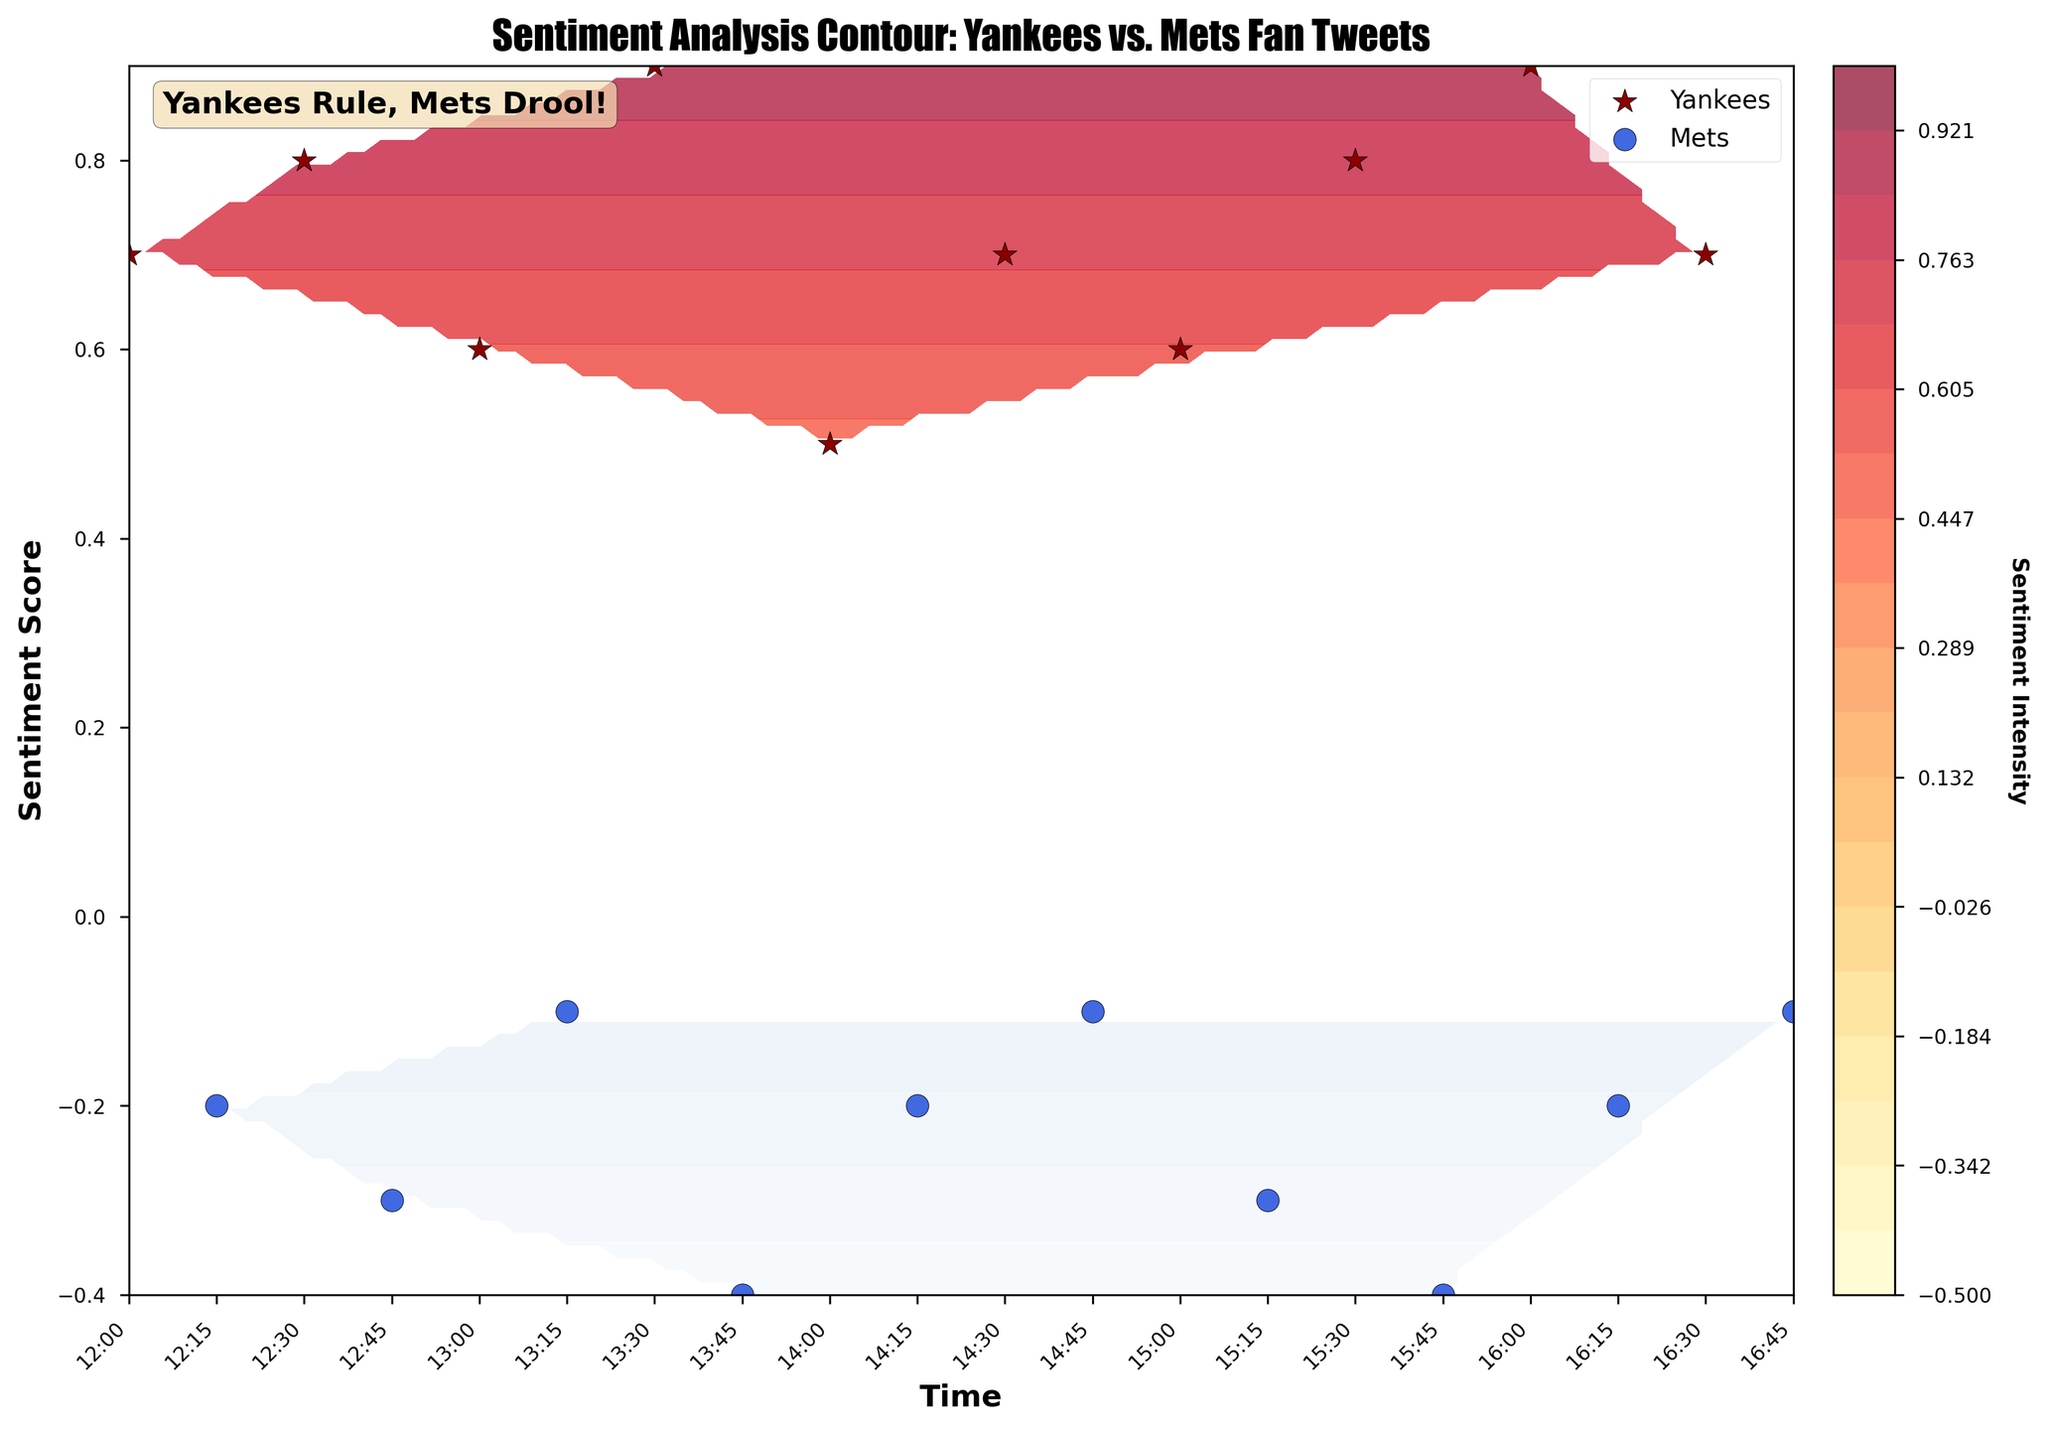What's the title of the figure? The title is located at the top of the plot and is typically in a larger font size to distinguish it as the main heading. In this plot, the title states the main topic which is "Sentiment Analysis Contour: Yankees vs. Mets Fan Tweets".
Answer: Sentiment Analysis Contour: Yankees vs. Mets Fan Tweets What do the colors red and blue represent in the contour plot? The color red corresponds to the Yankees data, indicating areas of positive sentiment, and blue corresponds to the Mets data, indicating areas of negative sentiment. This is reinforced by the legend and the contour fill colors used.
Answer: Red for Yankees, Blue for Mets What is the highest sentiment score shown for Yankees fans? To find the highest sentiment score, look for the topmost point on the vertical axis where Yankees data is plotted (marked with red star markers). The highest point is around 0.9.
Answer: 0.9 How many Mets sentiment points are plotted? This can be counted by the number of blue circle markers on the plot. By visually inspecting, there are eight blue circle markers corresponding to Mets sentiment points.
Answer: 8 Which team has more positive sentiment tweets? Positive sentiment is shown by the point's position above zero on the sentiment axis. The Yankees have multiple points above zero while Mets have all points below zero. Hence, Yankees have more positive sentiment tweets.
Answer: Yankees How does the sentiment score for Yankees change over time? By following the red star markers from left to right (which represents time), you can see the Yankee's sentiment score starts positive and fluctuates but remains largely positive throughout.
Answer: Largely positive What is the sentiment intensity color bar label? This label is displayed next to the color bar usually and indicates what the colors represent. Here, it is labeled "Sentiment Intensity" with a vertical orientation.
Answer: Sentiment Intensity What time range do the tweets cover in the plot? The time axis at the bottom shows the range. By looking at the first and last timestamps, we see it ranges from 12:00 to 16:45.
Answer: 12:00 to 16:45 In the figure, how many Yankees fan tweets are plotted compared to Mets fan tweets? By counting the markers: red stars for Yankees and blue circles for Mets, we observe there are 10 Yankees tweets and 8 Mets tweets.
Answer: Yankees: 10, Mets: 8 Who has the most intense positive sentiment among Yankees fans and Mets fans? This can be determined by identifying the highest sentiment score on the plot. Yankees fans have a highest sentiment score of 0.9, while Mets never go positive, indicating Yankees fans show the most intense positive sentiment.
Answer: Yankees fans 